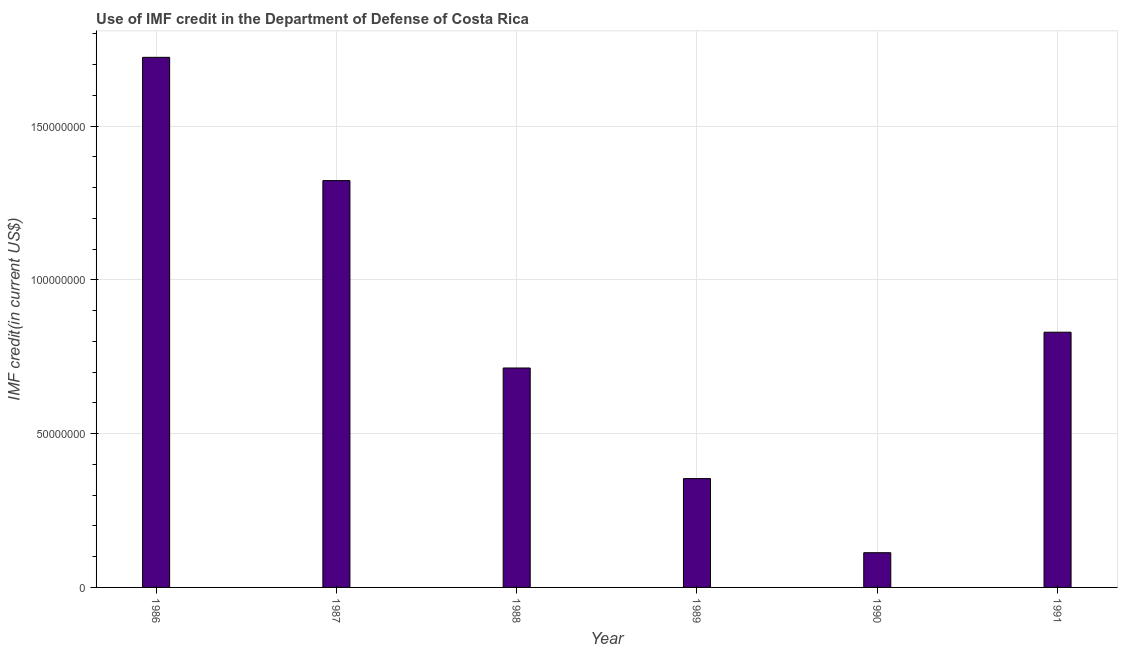What is the title of the graph?
Ensure brevity in your answer.  Use of IMF credit in the Department of Defense of Costa Rica. What is the label or title of the Y-axis?
Give a very brief answer. IMF credit(in current US$). What is the use of imf credit in dod in 1988?
Your answer should be compact. 7.14e+07. Across all years, what is the maximum use of imf credit in dod?
Your answer should be compact. 1.72e+08. Across all years, what is the minimum use of imf credit in dod?
Offer a very short reply. 1.13e+07. In which year was the use of imf credit in dod maximum?
Ensure brevity in your answer.  1986. What is the sum of the use of imf credit in dod?
Offer a terse response. 5.06e+08. What is the difference between the use of imf credit in dod in 1989 and 1991?
Ensure brevity in your answer.  -4.76e+07. What is the average use of imf credit in dod per year?
Offer a very short reply. 8.43e+07. What is the median use of imf credit in dod?
Your response must be concise. 7.72e+07. What is the ratio of the use of imf credit in dod in 1986 to that in 1991?
Offer a very short reply. 2.08. Is the use of imf credit in dod in 1987 less than that in 1989?
Your answer should be compact. No. Is the difference between the use of imf credit in dod in 1989 and 1991 greater than the difference between any two years?
Offer a very short reply. No. What is the difference between the highest and the second highest use of imf credit in dod?
Keep it short and to the point. 4.01e+07. Is the sum of the use of imf credit in dod in 1989 and 1990 greater than the maximum use of imf credit in dod across all years?
Make the answer very short. No. What is the difference between the highest and the lowest use of imf credit in dod?
Keep it short and to the point. 1.61e+08. How many years are there in the graph?
Your answer should be compact. 6. What is the difference between two consecutive major ticks on the Y-axis?
Provide a succinct answer. 5.00e+07. What is the IMF credit(in current US$) in 1986?
Ensure brevity in your answer.  1.72e+08. What is the IMF credit(in current US$) in 1987?
Provide a succinct answer. 1.32e+08. What is the IMF credit(in current US$) of 1988?
Provide a succinct answer. 7.14e+07. What is the IMF credit(in current US$) of 1989?
Your answer should be compact. 3.54e+07. What is the IMF credit(in current US$) of 1990?
Ensure brevity in your answer.  1.13e+07. What is the IMF credit(in current US$) of 1991?
Your answer should be compact. 8.30e+07. What is the difference between the IMF credit(in current US$) in 1986 and 1987?
Provide a short and direct response. 4.01e+07. What is the difference between the IMF credit(in current US$) in 1986 and 1988?
Provide a succinct answer. 1.01e+08. What is the difference between the IMF credit(in current US$) in 1986 and 1989?
Offer a very short reply. 1.37e+08. What is the difference between the IMF credit(in current US$) in 1986 and 1990?
Offer a terse response. 1.61e+08. What is the difference between the IMF credit(in current US$) in 1986 and 1991?
Provide a succinct answer. 8.94e+07. What is the difference between the IMF credit(in current US$) in 1987 and 1988?
Ensure brevity in your answer.  6.09e+07. What is the difference between the IMF credit(in current US$) in 1987 and 1989?
Provide a short and direct response. 9.69e+07. What is the difference between the IMF credit(in current US$) in 1987 and 1990?
Your answer should be compact. 1.21e+08. What is the difference between the IMF credit(in current US$) in 1987 and 1991?
Make the answer very short. 4.93e+07. What is the difference between the IMF credit(in current US$) in 1988 and 1989?
Your response must be concise. 3.60e+07. What is the difference between the IMF credit(in current US$) in 1988 and 1990?
Your answer should be compact. 6.01e+07. What is the difference between the IMF credit(in current US$) in 1988 and 1991?
Offer a very short reply. -1.16e+07. What is the difference between the IMF credit(in current US$) in 1989 and 1990?
Ensure brevity in your answer.  2.41e+07. What is the difference between the IMF credit(in current US$) in 1989 and 1991?
Ensure brevity in your answer.  -4.76e+07. What is the difference between the IMF credit(in current US$) in 1990 and 1991?
Give a very brief answer. -7.17e+07. What is the ratio of the IMF credit(in current US$) in 1986 to that in 1987?
Ensure brevity in your answer.  1.3. What is the ratio of the IMF credit(in current US$) in 1986 to that in 1988?
Keep it short and to the point. 2.42. What is the ratio of the IMF credit(in current US$) in 1986 to that in 1989?
Your answer should be compact. 4.87. What is the ratio of the IMF credit(in current US$) in 1986 to that in 1990?
Your response must be concise. 15.27. What is the ratio of the IMF credit(in current US$) in 1986 to that in 1991?
Offer a very short reply. 2.08. What is the ratio of the IMF credit(in current US$) in 1987 to that in 1988?
Give a very brief answer. 1.85. What is the ratio of the IMF credit(in current US$) in 1987 to that in 1989?
Keep it short and to the point. 3.74. What is the ratio of the IMF credit(in current US$) in 1987 to that in 1990?
Provide a succinct answer. 11.72. What is the ratio of the IMF credit(in current US$) in 1987 to that in 1991?
Your answer should be compact. 1.59. What is the ratio of the IMF credit(in current US$) in 1988 to that in 1989?
Keep it short and to the point. 2.02. What is the ratio of the IMF credit(in current US$) in 1988 to that in 1990?
Provide a succinct answer. 6.32. What is the ratio of the IMF credit(in current US$) in 1988 to that in 1991?
Make the answer very short. 0.86. What is the ratio of the IMF credit(in current US$) in 1989 to that in 1990?
Give a very brief answer. 3.13. What is the ratio of the IMF credit(in current US$) in 1989 to that in 1991?
Offer a very short reply. 0.43. What is the ratio of the IMF credit(in current US$) in 1990 to that in 1991?
Ensure brevity in your answer.  0.14. 